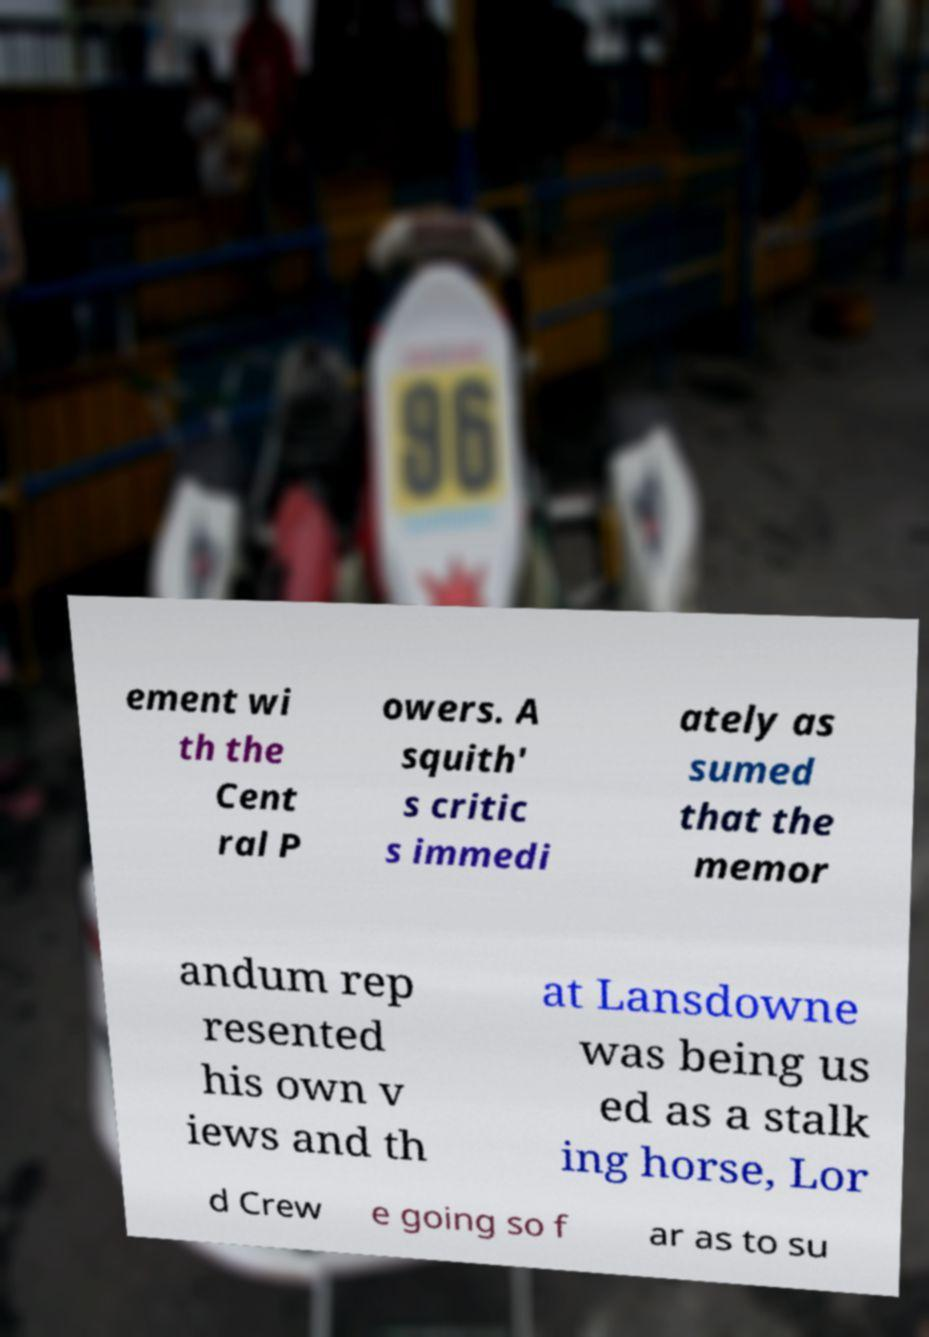I need the written content from this picture converted into text. Can you do that? ement wi th the Cent ral P owers. A squith' s critic s immedi ately as sumed that the memor andum rep resented his own v iews and th at Lansdowne was being us ed as a stalk ing horse, Lor d Crew e going so f ar as to su 